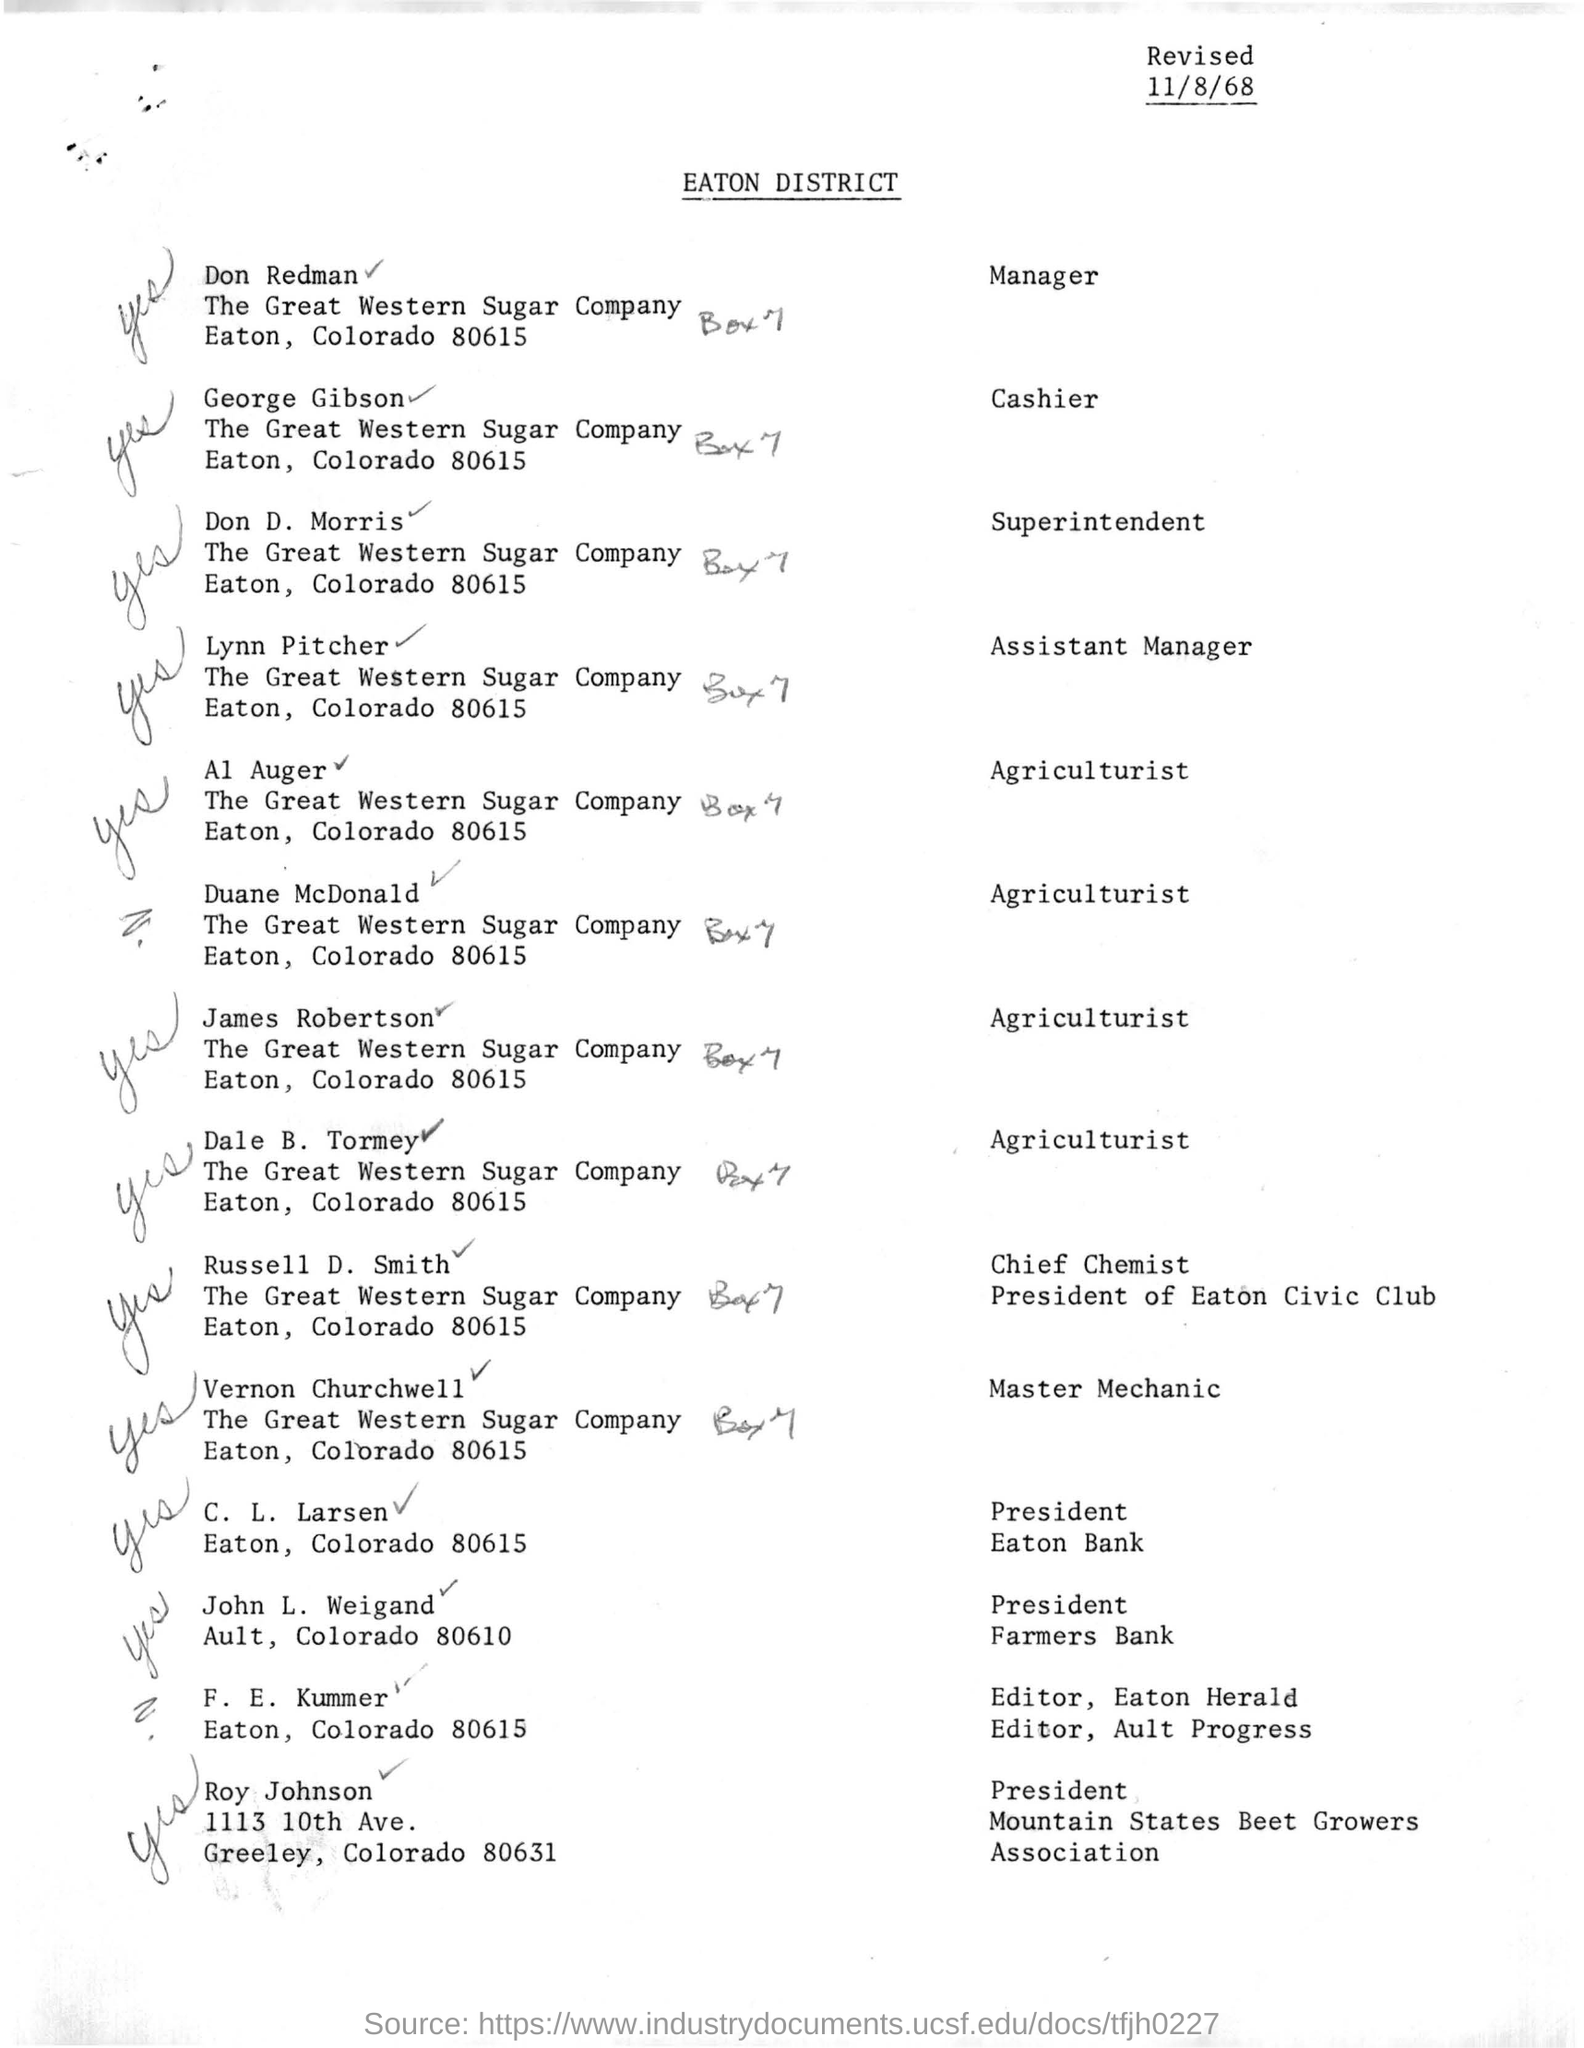Which company is cashier george gibson is associated with
Provide a succinct answer. The Great Western Sugar Company. Heading of the document
Offer a terse response. Eaton district. Where is the great western sugar company located at
Offer a terse response. Eaton, Colorado 80615. 